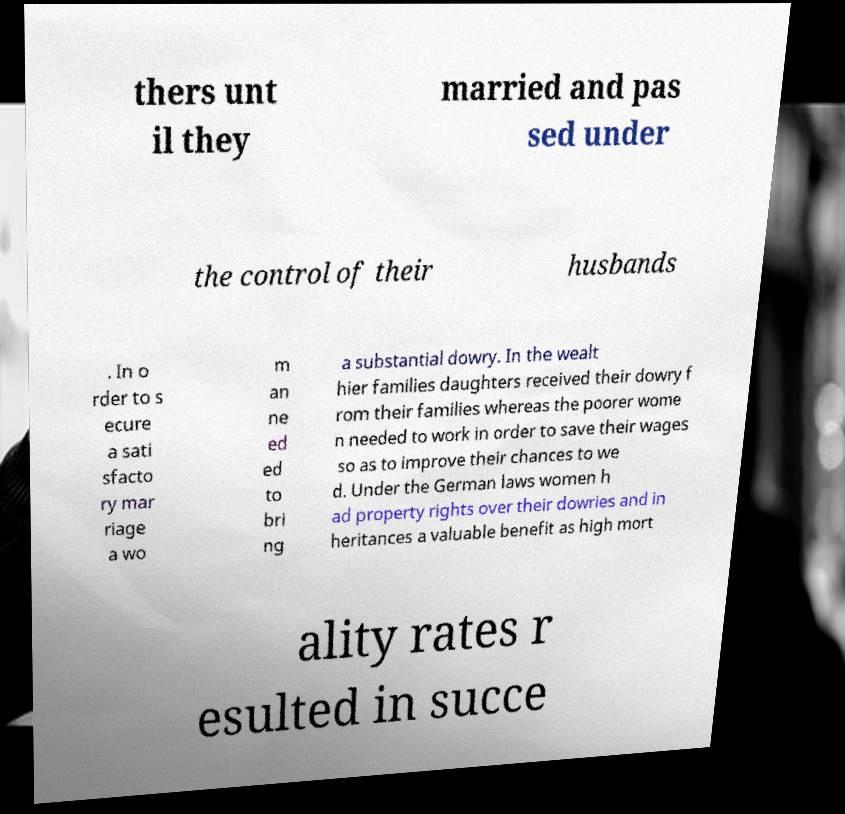What messages or text are displayed in this image? I need them in a readable, typed format. thers unt il they married and pas sed under the control of their husbands . In o rder to s ecure a sati sfacto ry mar riage a wo m an ne ed ed to bri ng a substantial dowry. In the wealt hier families daughters received their dowry f rom their families whereas the poorer wome n needed to work in order to save their wages so as to improve their chances to we d. Under the German laws women h ad property rights over their dowries and in heritances a valuable benefit as high mort ality rates r esulted in succe 